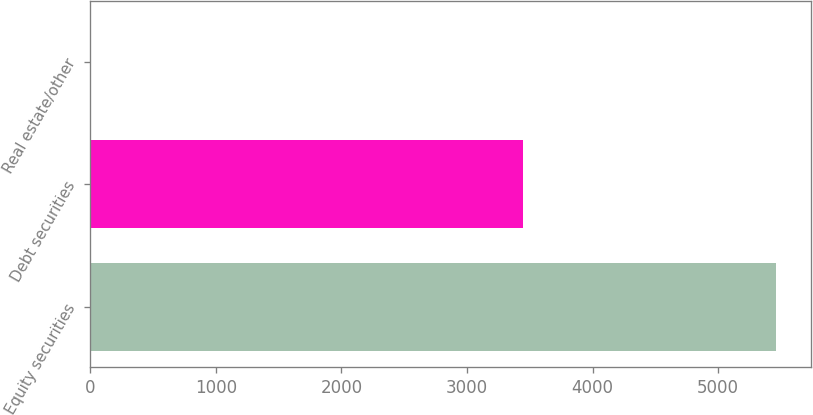Convert chart to OTSL. <chart><loc_0><loc_0><loc_500><loc_500><bar_chart><fcel>Equity securities<fcel>Debt securities<fcel>Real estate/other<nl><fcel>5465<fcel>3445<fcel>2<nl></chart> 